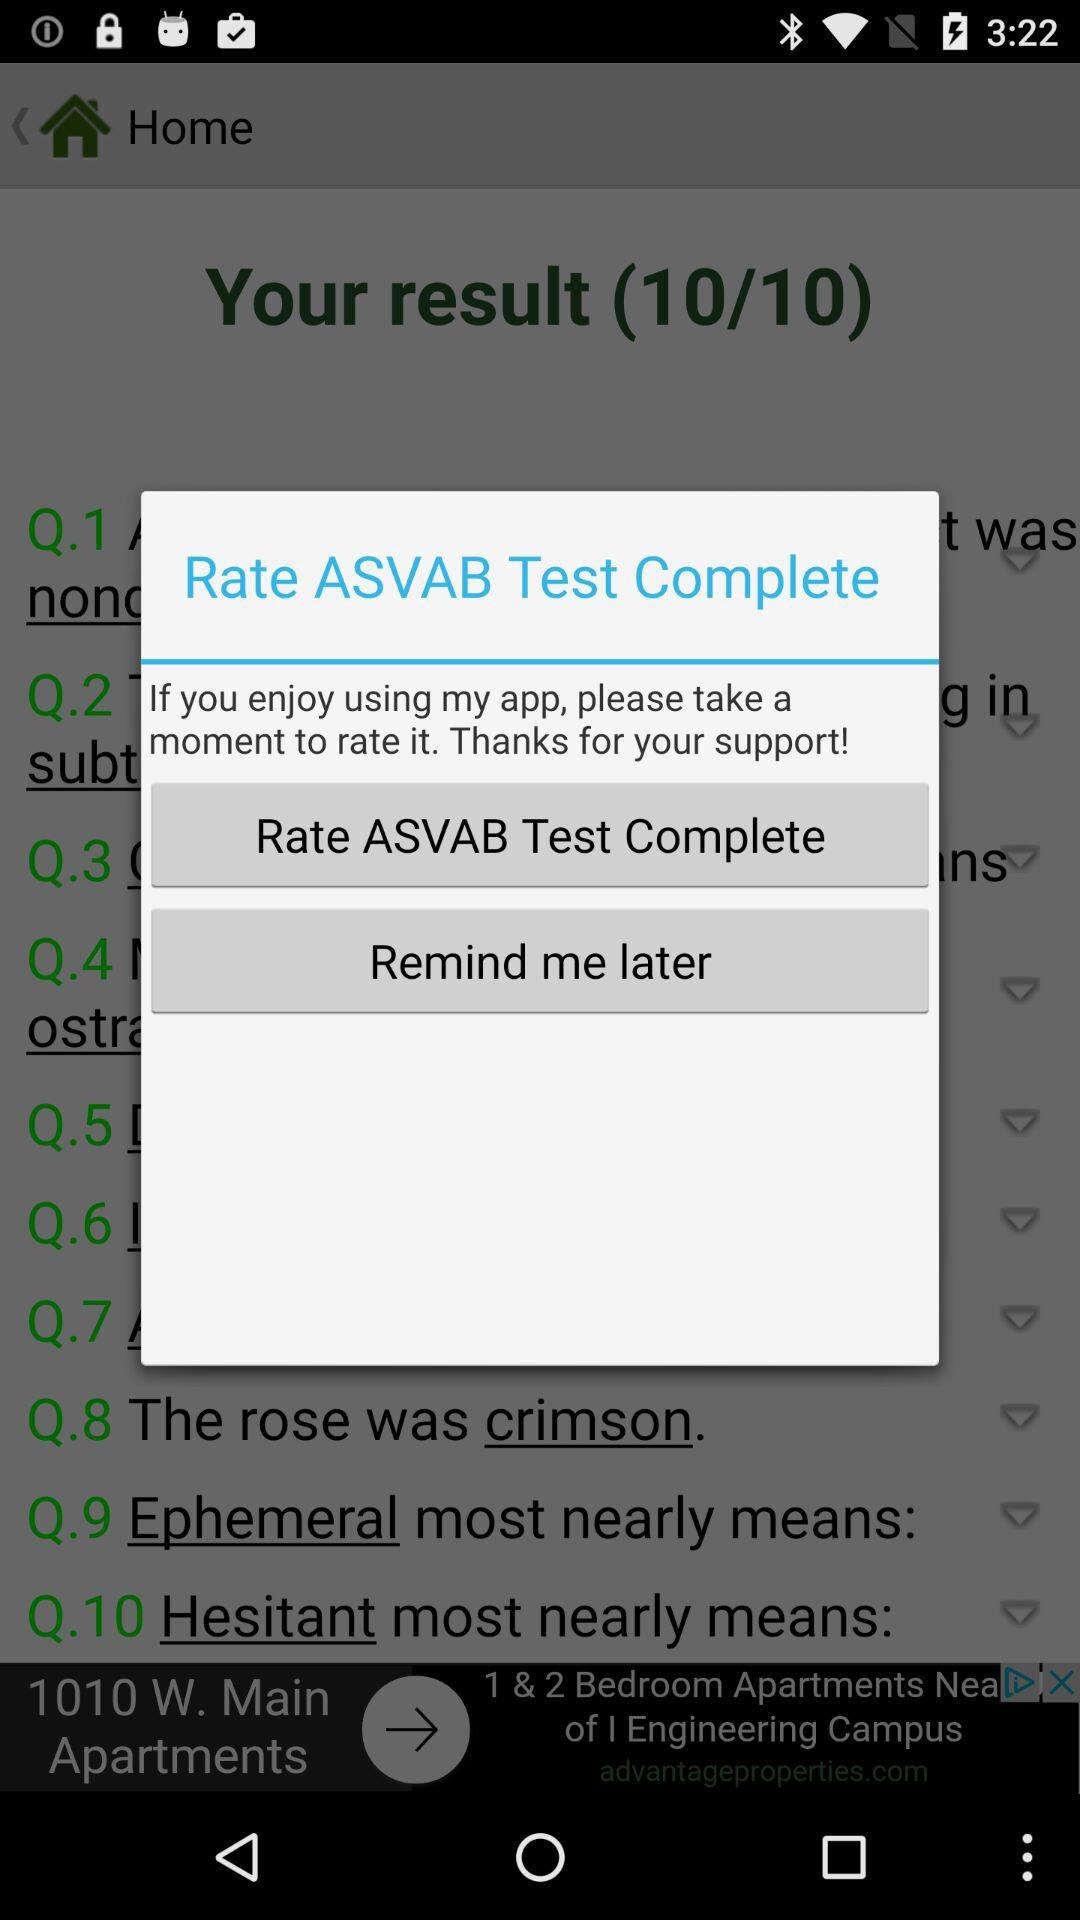What is the app name? The app name is "ASVAB Test Complete". 